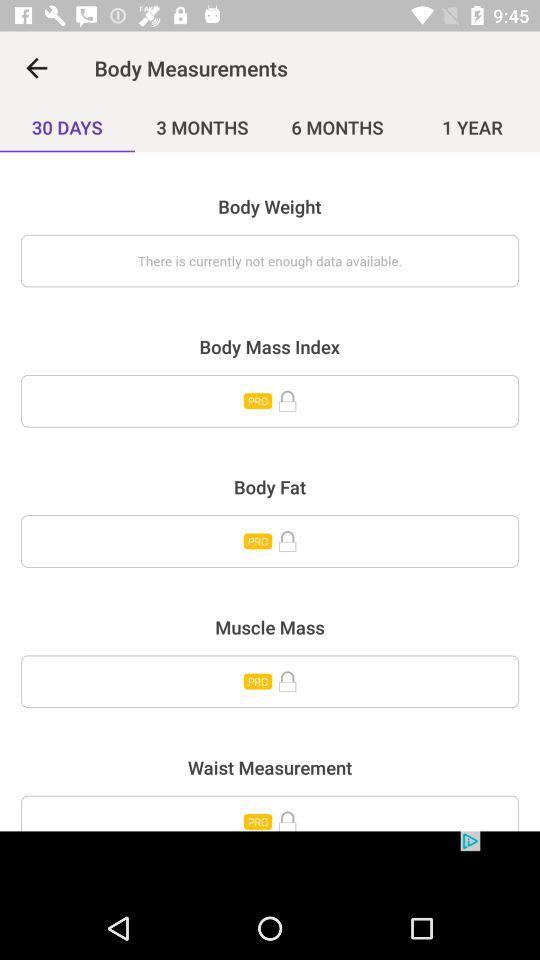What is the application name?
When the provided information is insufficient, respond with <no answer>. <no answer> 